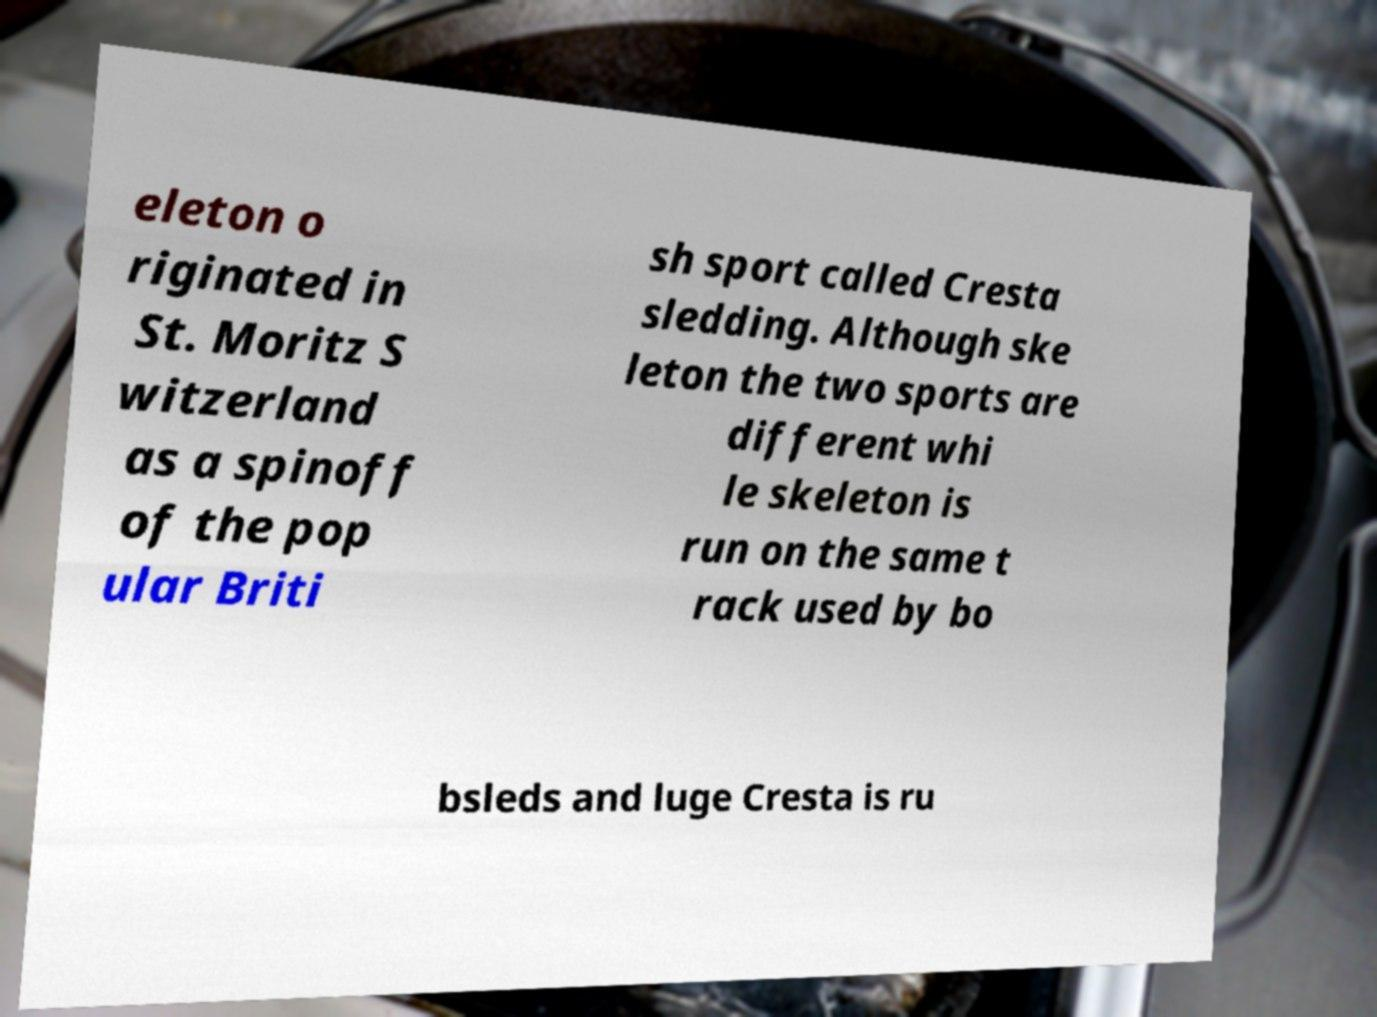For documentation purposes, I need the text within this image transcribed. Could you provide that? eleton o riginated in St. Moritz S witzerland as a spinoff of the pop ular Briti sh sport called Cresta sledding. Although ske leton the two sports are different whi le skeleton is run on the same t rack used by bo bsleds and luge Cresta is ru 